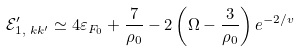Convert formula to latex. <formula><loc_0><loc_0><loc_500><loc_500>\mathcal { E } _ { 1 , \text { } k k ^ { \prime } } ^ { \prime } \simeq 4 \varepsilon _ { F _ { 0 } } + \frac { 7 } { \rho _ { 0 } } - 2 \left ( \Omega - \frac { 3 } { \rho _ { 0 } } \right ) e ^ { - 2 / v }</formula> 